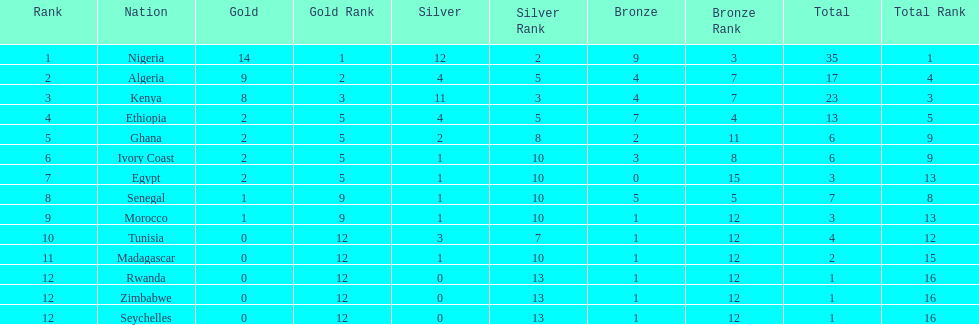Total number of bronze medals nigeria earned? 9. 